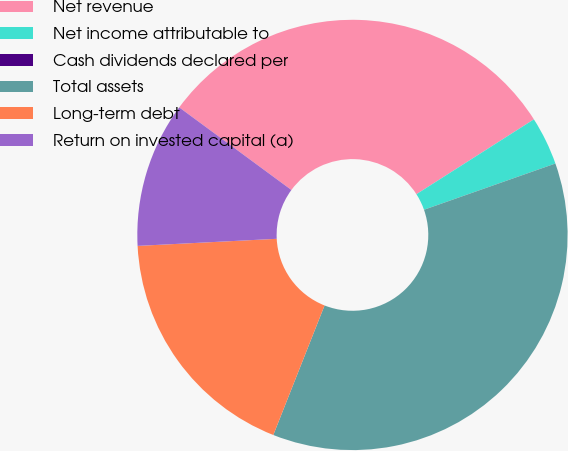<chart> <loc_0><loc_0><loc_500><loc_500><pie_chart><fcel>Net revenue<fcel>Net income attributable to<fcel>Cash dividends declared per<fcel>Total assets<fcel>Long-term debt<fcel>Return on invested capital (a)<nl><fcel>30.87%<fcel>3.64%<fcel>0.0%<fcel>36.38%<fcel>18.19%<fcel>10.91%<nl></chart> 